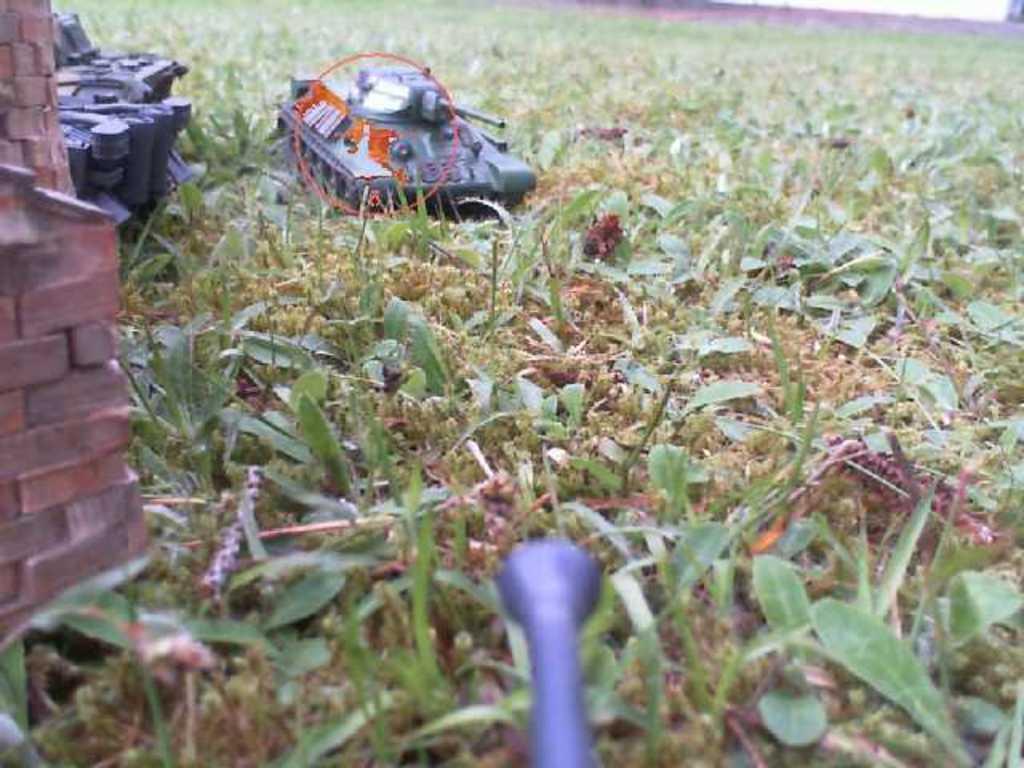Describe this image in one or two sentences. Here we can see small plants on the ground. On the left there is a toy military tank vehicle,small bricks and an object on the ground. At the bottom there is an object. 